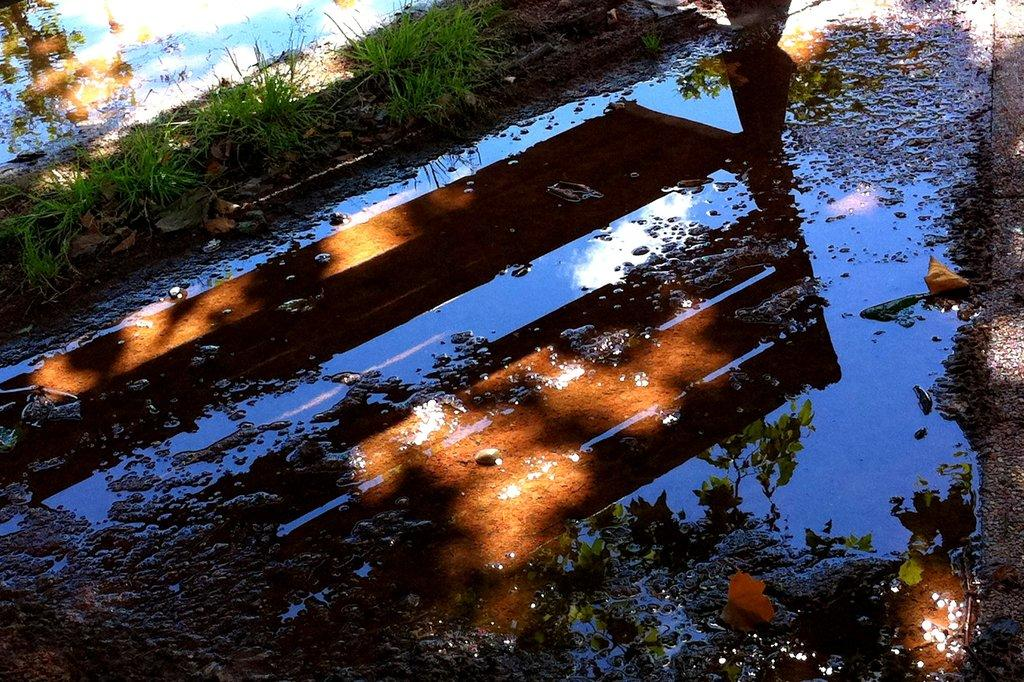What natural element can be seen in the image? Water and grass are visible in the image. What is the condition of the water in the image? The reflection of the sky is visible in the water. Can you tell me how many quinces are floating in the water in the image? There are no quinces present in the image; it features water and grass. What type of operation is being performed on the writer in the image? There is no writer or any operation being performed in the image. 